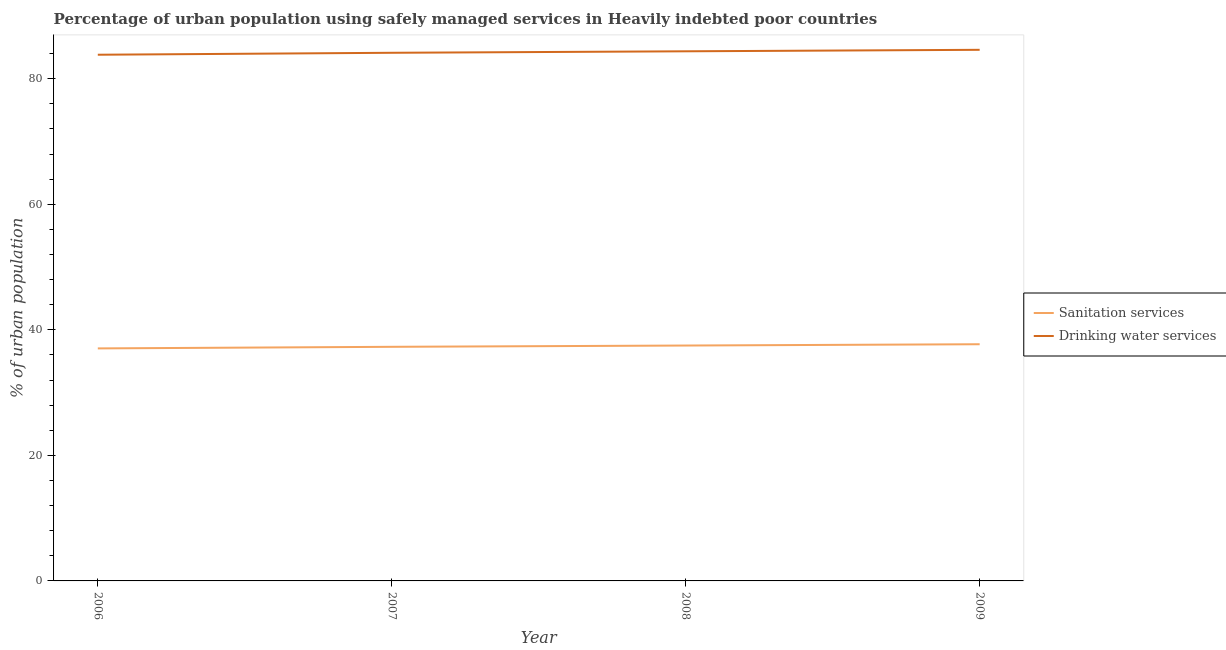Is the number of lines equal to the number of legend labels?
Keep it short and to the point. Yes. What is the percentage of urban population who used sanitation services in 2007?
Provide a short and direct response. 37.29. Across all years, what is the maximum percentage of urban population who used sanitation services?
Your response must be concise. 37.7. Across all years, what is the minimum percentage of urban population who used drinking water services?
Your answer should be compact. 83.81. What is the total percentage of urban population who used drinking water services in the graph?
Keep it short and to the point. 336.89. What is the difference between the percentage of urban population who used sanitation services in 2008 and that in 2009?
Keep it short and to the point. -0.21. What is the difference between the percentage of urban population who used drinking water services in 2006 and the percentage of urban population who used sanitation services in 2008?
Your response must be concise. 46.32. What is the average percentage of urban population who used sanitation services per year?
Give a very brief answer. 37.38. In the year 2008, what is the difference between the percentage of urban population who used drinking water services and percentage of urban population who used sanitation services?
Your answer should be very brief. 46.87. In how many years, is the percentage of urban population who used sanitation services greater than 8 %?
Your answer should be compact. 4. What is the ratio of the percentage of urban population who used sanitation services in 2007 to that in 2008?
Your answer should be very brief. 0.99. Is the percentage of urban population who used drinking water services in 2008 less than that in 2009?
Give a very brief answer. Yes. Is the difference between the percentage of urban population who used sanitation services in 2007 and 2008 greater than the difference between the percentage of urban population who used drinking water services in 2007 and 2008?
Provide a short and direct response. Yes. What is the difference between the highest and the second highest percentage of urban population who used drinking water services?
Ensure brevity in your answer.  0.24. What is the difference between the highest and the lowest percentage of urban population who used sanitation services?
Ensure brevity in your answer.  0.66. In how many years, is the percentage of urban population who used drinking water services greater than the average percentage of urban population who used drinking water services taken over all years?
Your answer should be very brief. 2. Does the percentage of urban population who used sanitation services monotonically increase over the years?
Offer a very short reply. Yes. Is the percentage of urban population who used sanitation services strictly greater than the percentage of urban population who used drinking water services over the years?
Give a very brief answer. No. Is the percentage of urban population who used sanitation services strictly less than the percentage of urban population who used drinking water services over the years?
Provide a succinct answer. Yes. Does the graph contain any zero values?
Your response must be concise. No. How many legend labels are there?
Your answer should be compact. 2. How are the legend labels stacked?
Your answer should be very brief. Vertical. What is the title of the graph?
Provide a succinct answer. Percentage of urban population using safely managed services in Heavily indebted poor countries. What is the label or title of the X-axis?
Give a very brief answer. Year. What is the label or title of the Y-axis?
Offer a very short reply. % of urban population. What is the % of urban population of Sanitation services in 2006?
Your answer should be very brief. 37.04. What is the % of urban population of Drinking water services in 2006?
Make the answer very short. 83.81. What is the % of urban population of Sanitation services in 2007?
Keep it short and to the point. 37.29. What is the % of urban population in Drinking water services in 2007?
Give a very brief answer. 84.12. What is the % of urban population of Sanitation services in 2008?
Keep it short and to the point. 37.49. What is the % of urban population in Drinking water services in 2008?
Your response must be concise. 84.36. What is the % of urban population in Sanitation services in 2009?
Make the answer very short. 37.7. What is the % of urban population in Drinking water services in 2009?
Offer a terse response. 84.6. Across all years, what is the maximum % of urban population in Sanitation services?
Provide a succinct answer. 37.7. Across all years, what is the maximum % of urban population of Drinking water services?
Provide a succinct answer. 84.6. Across all years, what is the minimum % of urban population of Sanitation services?
Your response must be concise. 37.04. Across all years, what is the minimum % of urban population in Drinking water services?
Your answer should be compact. 83.81. What is the total % of urban population in Sanitation services in the graph?
Offer a terse response. 149.52. What is the total % of urban population in Drinking water services in the graph?
Your answer should be compact. 336.89. What is the difference between the % of urban population of Sanitation services in 2006 and that in 2007?
Offer a very short reply. -0.25. What is the difference between the % of urban population of Drinking water services in 2006 and that in 2007?
Ensure brevity in your answer.  -0.31. What is the difference between the % of urban population of Sanitation services in 2006 and that in 2008?
Your answer should be very brief. -0.46. What is the difference between the % of urban population of Drinking water services in 2006 and that in 2008?
Provide a succinct answer. -0.55. What is the difference between the % of urban population in Sanitation services in 2006 and that in 2009?
Offer a very short reply. -0.66. What is the difference between the % of urban population of Drinking water services in 2006 and that in 2009?
Provide a succinct answer. -0.79. What is the difference between the % of urban population of Sanitation services in 2007 and that in 2008?
Your answer should be compact. -0.2. What is the difference between the % of urban population of Drinking water services in 2007 and that in 2008?
Provide a short and direct response. -0.24. What is the difference between the % of urban population in Sanitation services in 2007 and that in 2009?
Provide a succinct answer. -0.41. What is the difference between the % of urban population in Drinking water services in 2007 and that in 2009?
Your answer should be very brief. -0.48. What is the difference between the % of urban population in Sanitation services in 2008 and that in 2009?
Offer a very short reply. -0.21. What is the difference between the % of urban population in Drinking water services in 2008 and that in 2009?
Provide a short and direct response. -0.24. What is the difference between the % of urban population in Sanitation services in 2006 and the % of urban population in Drinking water services in 2007?
Give a very brief answer. -47.09. What is the difference between the % of urban population of Sanitation services in 2006 and the % of urban population of Drinking water services in 2008?
Keep it short and to the point. -47.32. What is the difference between the % of urban population of Sanitation services in 2006 and the % of urban population of Drinking water services in 2009?
Your answer should be very brief. -47.56. What is the difference between the % of urban population of Sanitation services in 2007 and the % of urban population of Drinking water services in 2008?
Ensure brevity in your answer.  -47.07. What is the difference between the % of urban population of Sanitation services in 2007 and the % of urban population of Drinking water services in 2009?
Your answer should be very brief. -47.31. What is the difference between the % of urban population of Sanitation services in 2008 and the % of urban population of Drinking water services in 2009?
Make the answer very short. -47.1. What is the average % of urban population of Sanitation services per year?
Your response must be concise. 37.38. What is the average % of urban population in Drinking water services per year?
Provide a succinct answer. 84.22. In the year 2006, what is the difference between the % of urban population of Sanitation services and % of urban population of Drinking water services?
Offer a terse response. -46.78. In the year 2007, what is the difference between the % of urban population of Sanitation services and % of urban population of Drinking water services?
Give a very brief answer. -46.83. In the year 2008, what is the difference between the % of urban population of Sanitation services and % of urban population of Drinking water services?
Your answer should be compact. -46.87. In the year 2009, what is the difference between the % of urban population of Sanitation services and % of urban population of Drinking water services?
Offer a terse response. -46.9. What is the ratio of the % of urban population in Sanitation services in 2006 to that in 2008?
Your response must be concise. 0.99. What is the ratio of the % of urban population of Sanitation services in 2006 to that in 2009?
Make the answer very short. 0.98. What is the ratio of the % of urban population of Drinking water services in 2007 to that in 2008?
Give a very brief answer. 1. What is the ratio of the % of urban population in Sanitation services in 2007 to that in 2009?
Your response must be concise. 0.99. What is the ratio of the % of urban population of Sanitation services in 2008 to that in 2009?
Offer a terse response. 0.99. What is the ratio of the % of urban population of Drinking water services in 2008 to that in 2009?
Offer a terse response. 1. What is the difference between the highest and the second highest % of urban population in Sanitation services?
Give a very brief answer. 0.21. What is the difference between the highest and the second highest % of urban population of Drinking water services?
Keep it short and to the point. 0.24. What is the difference between the highest and the lowest % of urban population of Sanitation services?
Offer a terse response. 0.66. What is the difference between the highest and the lowest % of urban population of Drinking water services?
Offer a terse response. 0.79. 